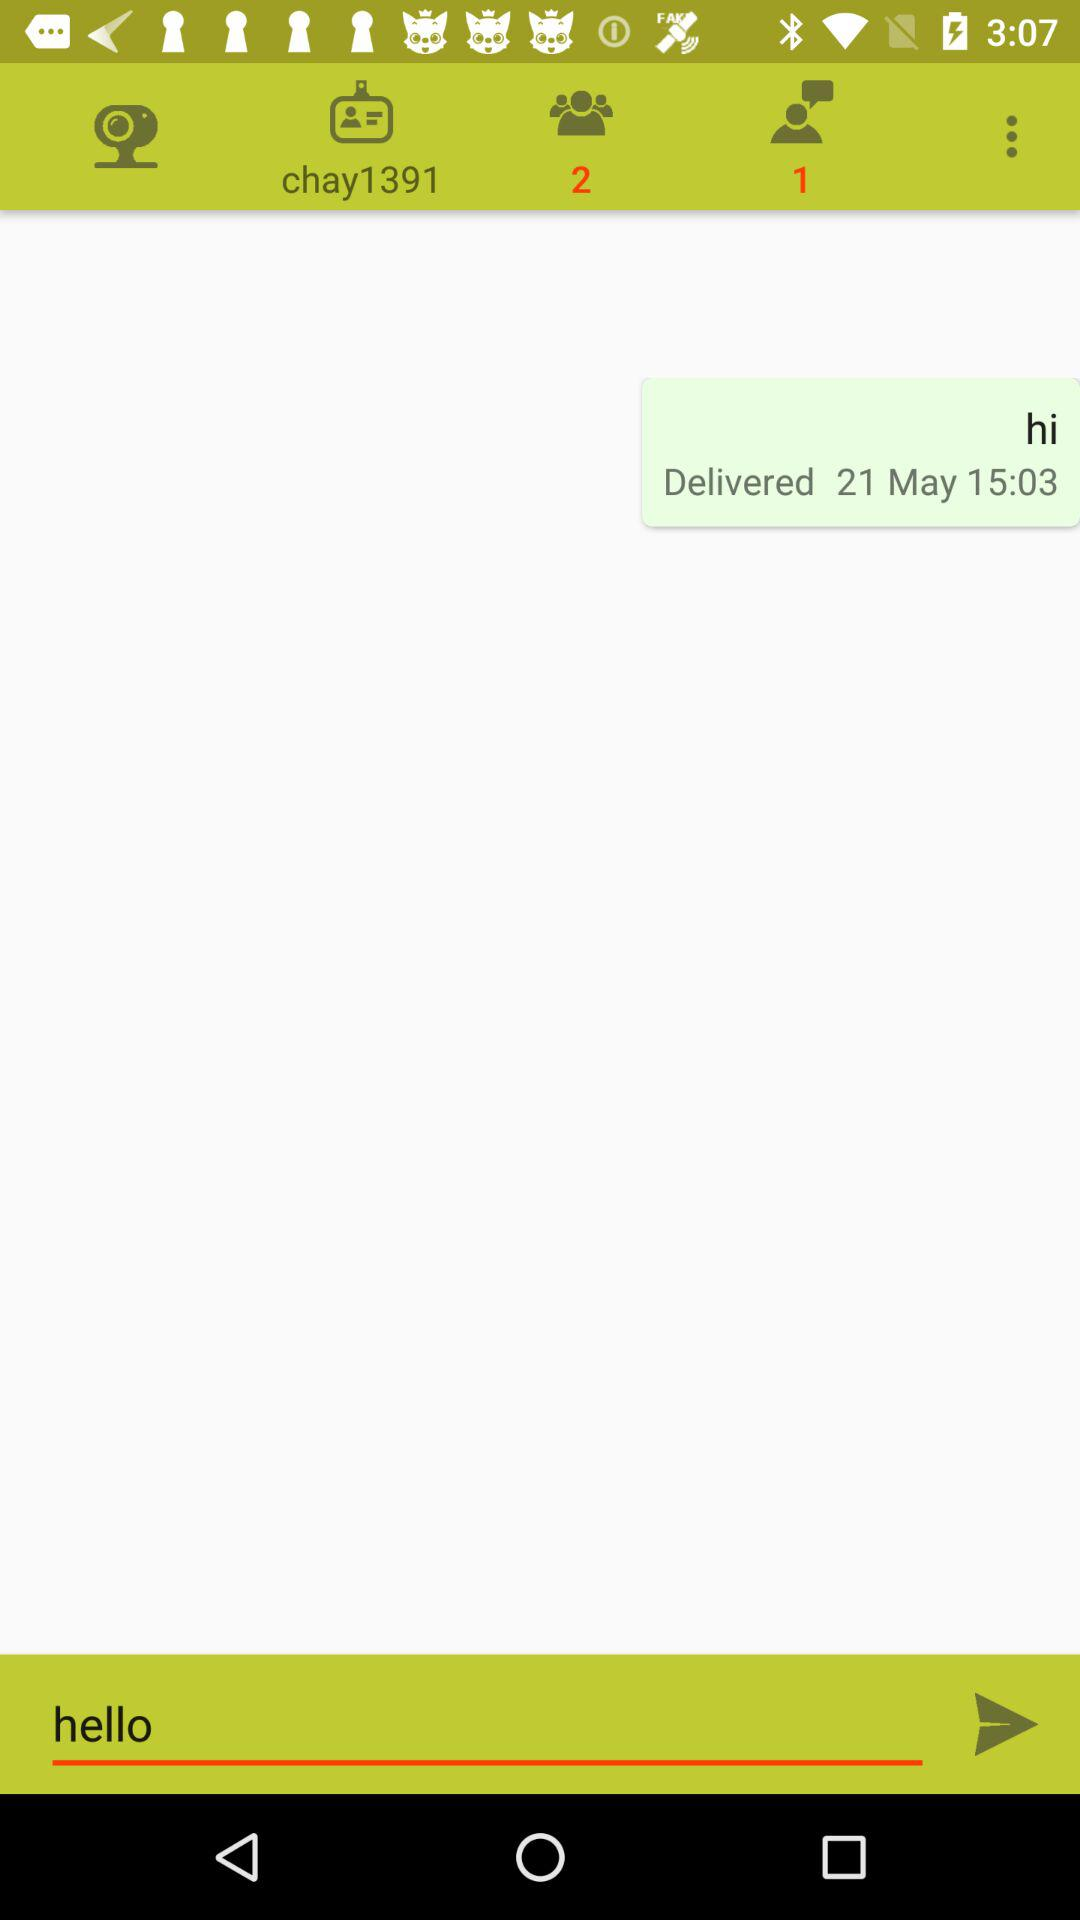How many more people are in the chat than there are unread messages? There is one person in the chat indicated by the user icon, and one unread message shown by the notification on the messaging app interface on the screen. Therefore, there are not more people in the chat than unread messages; both the number of people in the chat and the number of unread messages are equal. 